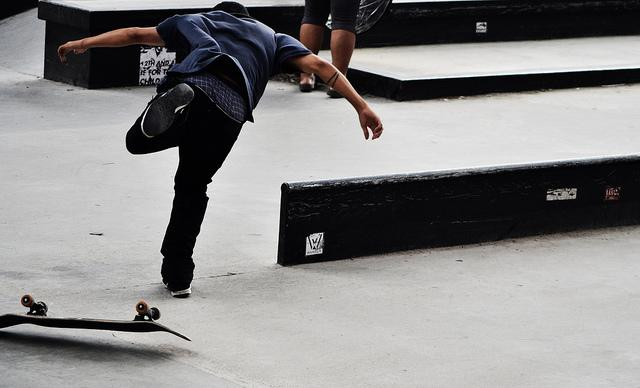How he is going to get hurt? Please explain your reasoning. falling. He's falling. 